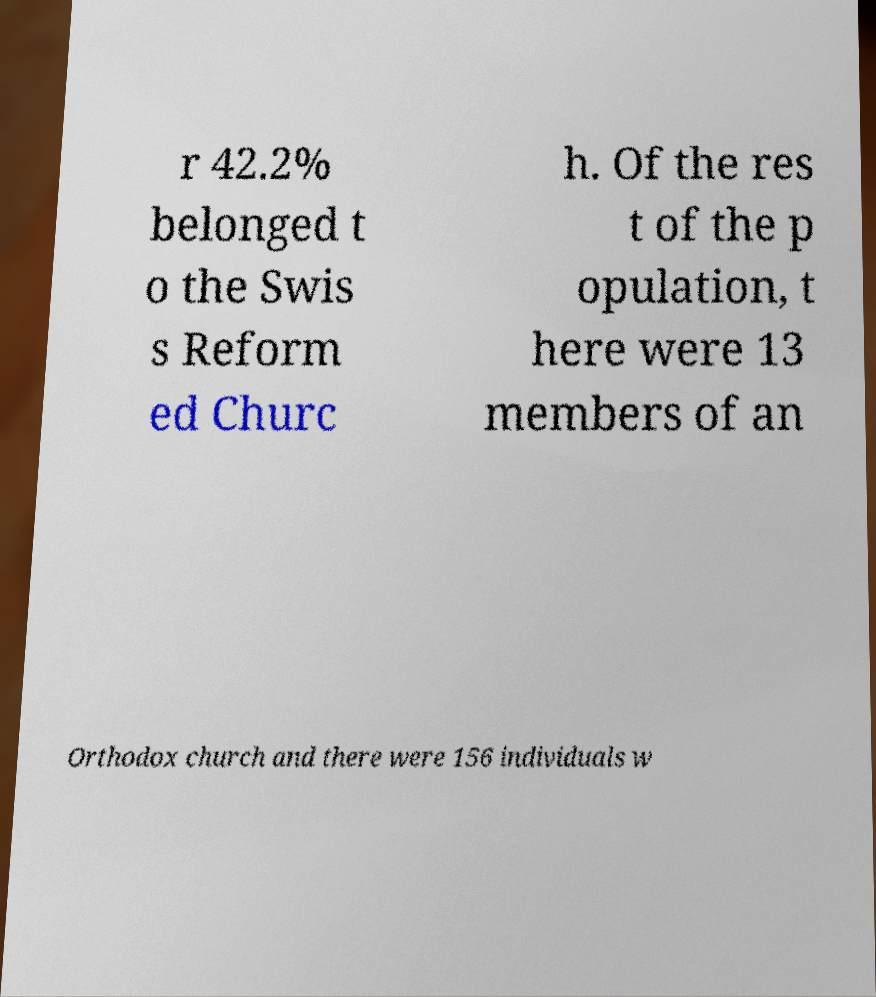Please read and relay the text visible in this image. What does it say? r 42.2% belonged t o the Swis s Reform ed Churc h. Of the res t of the p opulation, t here were 13 members of an Orthodox church and there were 156 individuals w 